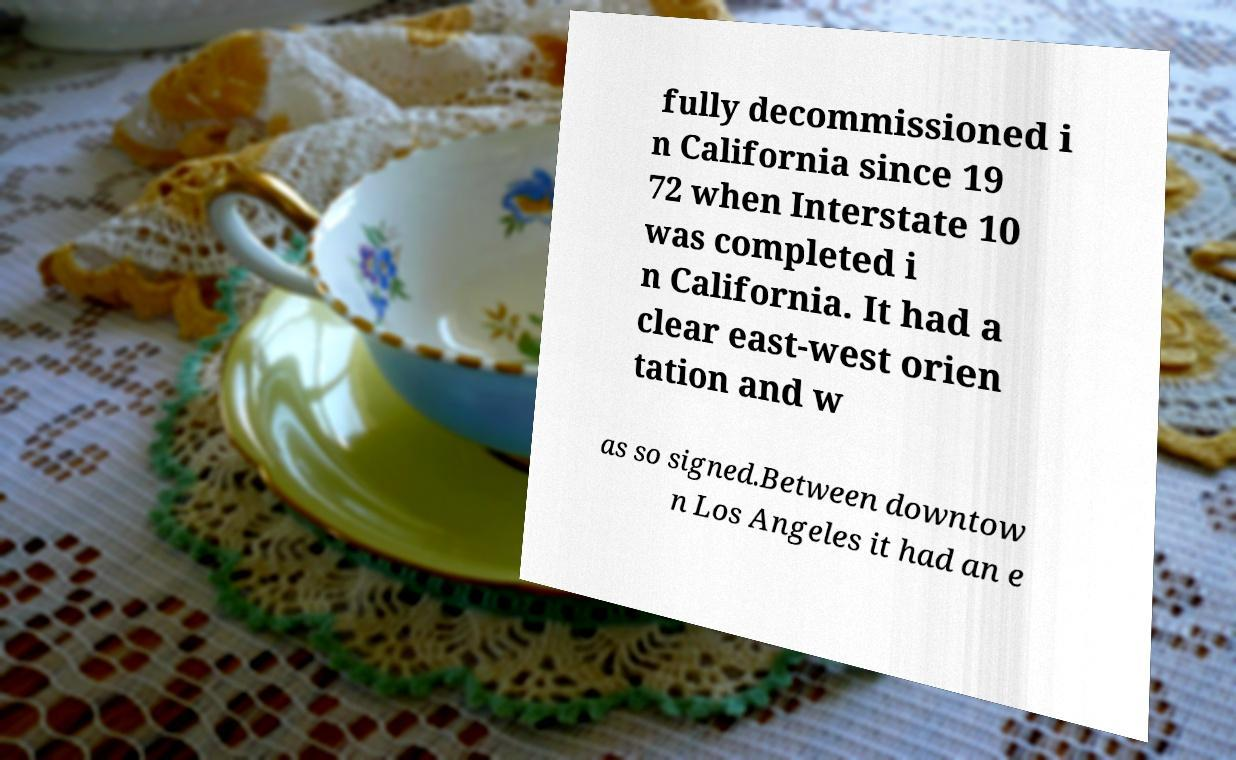For documentation purposes, I need the text within this image transcribed. Could you provide that? fully decommissioned i n California since 19 72 when Interstate 10 was completed i n California. It had a clear east-west orien tation and w as so signed.Between downtow n Los Angeles it had an e 